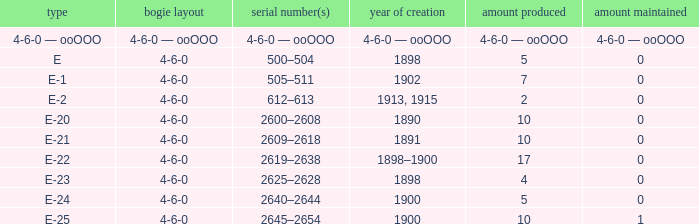What is the fleet number with a 4-6-0 wheel arrangement made in 1890? 2600–2608. 